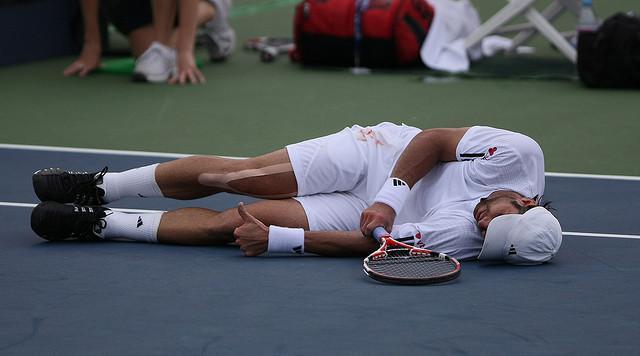How many people can you see?
Give a very brief answer. 2. 